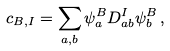<formula> <loc_0><loc_0><loc_500><loc_500>c _ { B , I } = \sum _ { a , b } \psi _ { a } ^ { B } D ^ { I } _ { a b } \psi _ { b } ^ { B } \, ,</formula> 